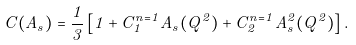Convert formula to latex. <formula><loc_0><loc_0><loc_500><loc_500>C ( A _ { s } ) = \frac { 1 } { 3 } \left [ 1 + C _ { 1 } ^ { n = 1 } A _ { s } ( Q ^ { 2 } ) + C _ { 2 } ^ { n = 1 } A _ { s } ^ { 2 } ( Q ^ { 2 } ) \right ] .</formula> 